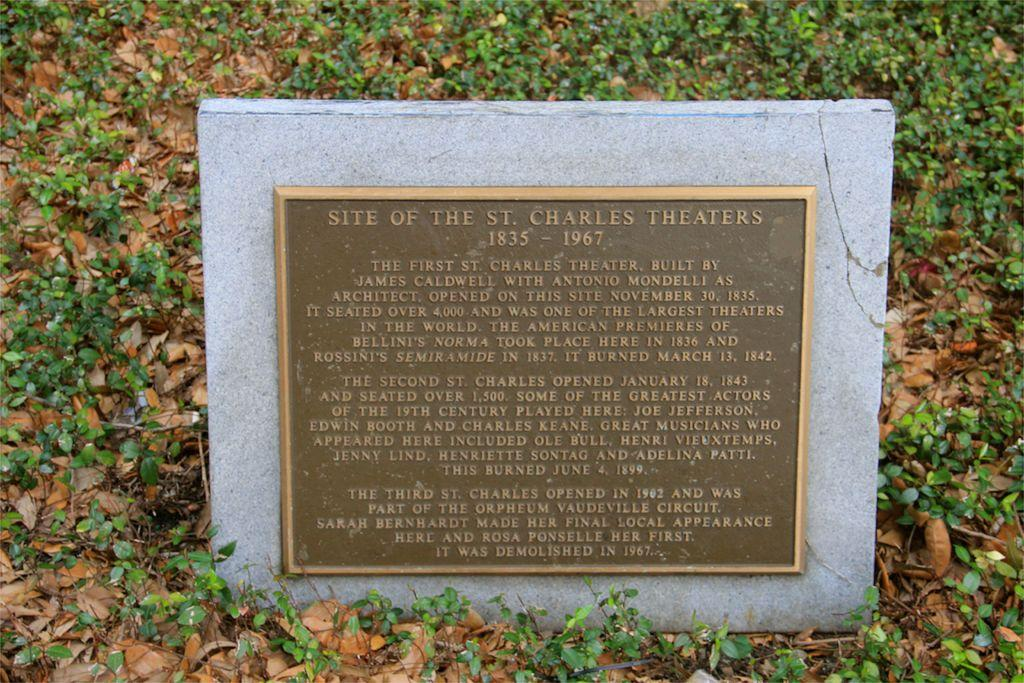What is the main subject of the image? There is a memorial in the image. What can be found on the memorial? The memorial has text on it. What can be seen in the background of the image? There is a group of plants in the background of the image. Can you see any horns on the memorial in the image? There are no horns present on the memorial in the image. Are there any cobwebs visible on the plants in the background? The presence of cobwebs cannot be determined from the image, as the focus is on the memorial and the plants are in the background. 